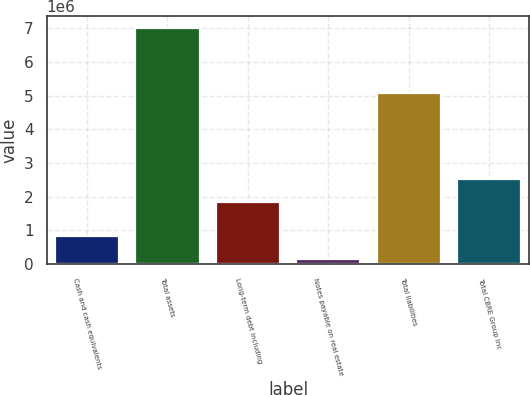Convert chart. <chart><loc_0><loc_0><loc_500><loc_500><bar_chart><fcel>Cash and cash equivalents<fcel>Total assets<fcel>Long-term debt including<fcel>Notes payable on real estate<fcel>Total liabilities<fcel>Total CBRE Group Inc<nl><fcel>817266<fcel>6.99841e+06<fcel>1.84068e+06<fcel>130472<fcel>5.06241e+06<fcel>2.52747e+06<nl></chart> 